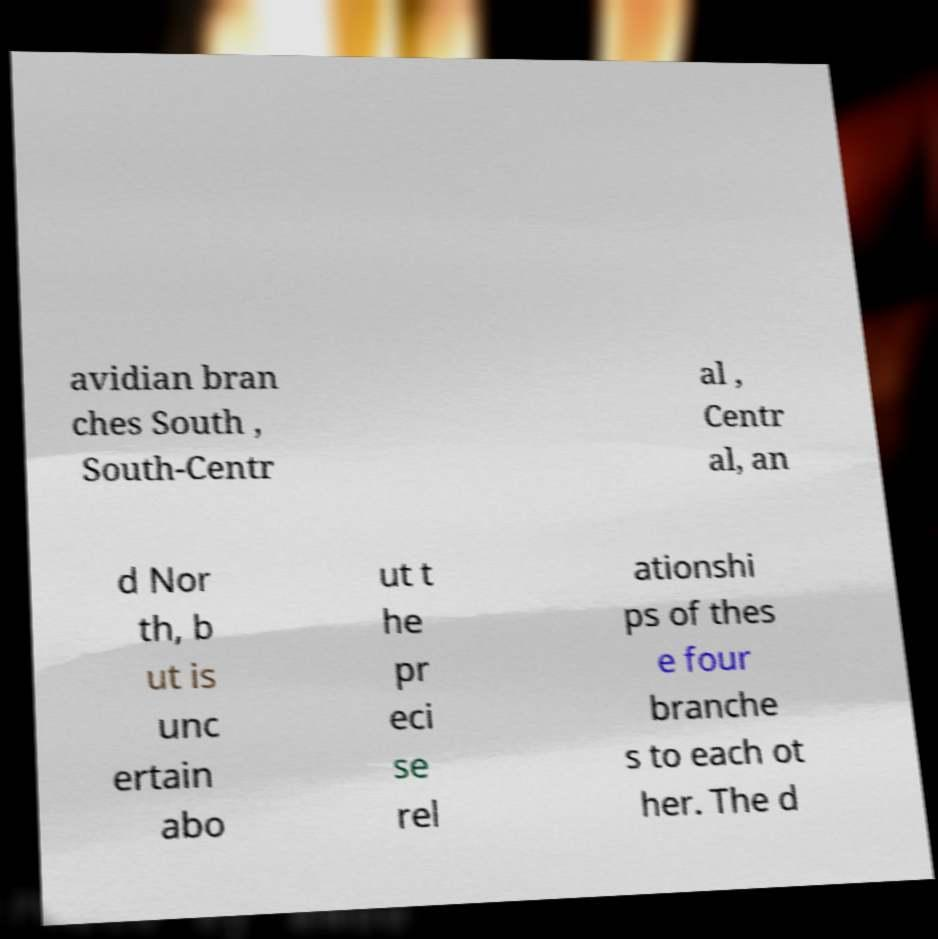Can you accurately transcribe the text from the provided image for me? avidian bran ches South , South-Centr al , Centr al, an d Nor th, b ut is unc ertain abo ut t he pr eci se rel ationshi ps of thes e four branche s to each ot her. The d 